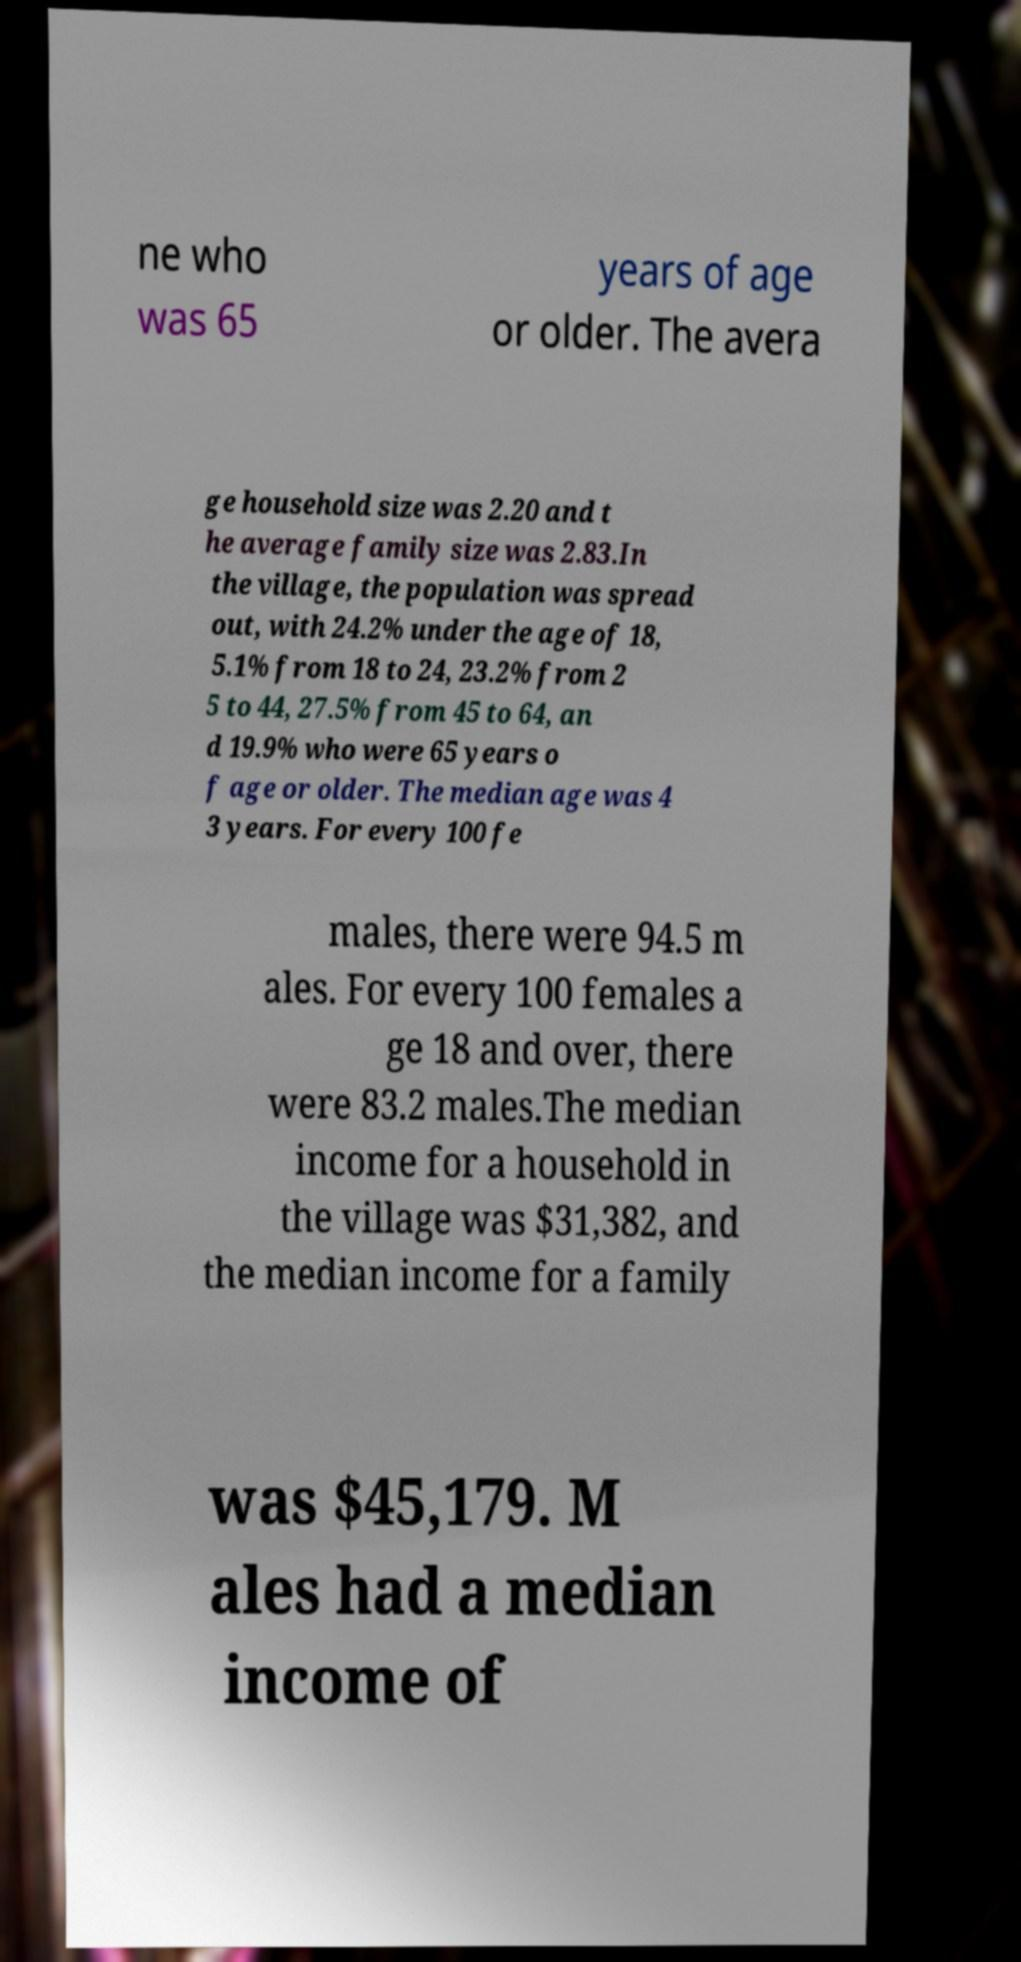Could you assist in decoding the text presented in this image and type it out clearly? ne who was 65 years of age or older. The avera ge household size was 2.20 and t he average family size was 2.83.In the village, the population was spread out, with 24.2% under the age of 18, 5.1% from 18 to 24, 23.2% from 2 5 to 44, 27.5% from 45 to 64, an d 19.9% who were 65 years o f age or older. The median age was 4 3 years. For every 100 fe males, there were 94.5 m ales. For every 100 females a ge 18 and over, there were 83.2 males.The median income for a household in the village was $31,382, and the median income for a family was $45,179. M ales had a median income of 